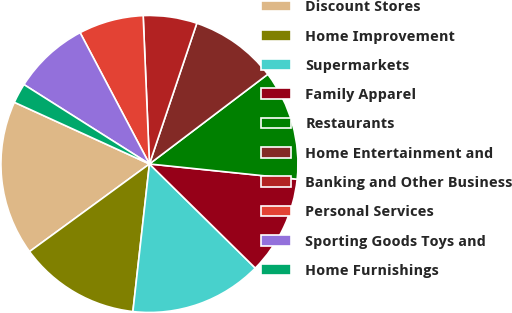Convert chart. <chart><loc_0><loc_0><loc_500><loc_500><pie_chart><fcel>Discount Stores<fcel>Home Improvement<fcel>Supermarkets<fcel>Family Apparel<fcel>Restaurants<fcel>Home Entertainment and<fcel>Banking and Other Business<fcel>Personal Services<fcel>Sporting Goods Toys and<fcel>Home Furnishings<nl><fcel>16.86%<fcel>13.18%<fcel>14.41%<fcel>10.73%<fcel>11.96%<fcel>9.51%<fcel>5.84%<fcel>7.06%<fcel>8.29%<fcel>2.16%<nl></chart> 